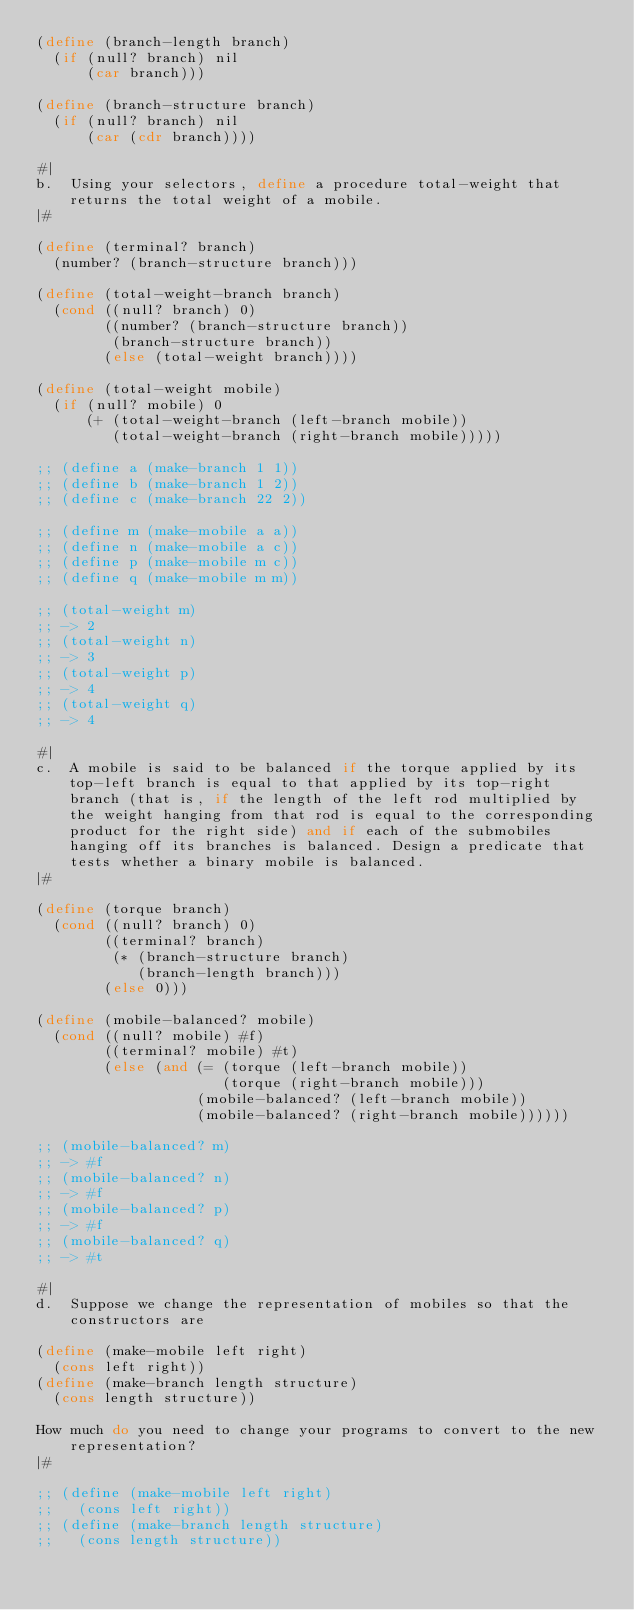Convert code to text. <code><loc_0><loc_0><loc_500><loc_500><_Scheme_>(define (branch-length branch)
  (if (null? branch) nil
      (car branch)))

(define (branch-structure branch)
  (if (null? branch) nil
      (car (cdr branch))))

#|
b.  Using your selectors, define a procedure total-weight that returns the total weight of a mobile.
|#

(define (terminal? branch)
  (number? (branch-structure branch)))

(define (total-weight-branch branch)
  (cond ((null? branch) 0)
        ((number? (branch-structure branch))
         (branch-structure branch))
        (else (total-weight branch))))

(define (total-weight mobile)
  (if (null? mobile) 0
      (+ (total-weight-branch (left-branch mobile))
         (total-weight-branch (right-branch mobile)))))

;; (define a (make-branch 1 1))
;; (define b (make-branch 1 2))
;; (define c (make-branch 22 2))

;; (define m (make-mobile a a))
;; (define n (make-mobile a c))
;; (define p (make-mobile m c))
;; (define q (make-mobile m m))

;; (total-weight m)
;; -> 2
;; (total-weight n)
;; -> 3
;; (total-weight p)
;; -> 4
;; (total-weight q)
;; -> 4

#|
c.  A mobile is said to be balanced if the torque applied by its top-left branch is equal to that applied by its top-right branch (that is, if the length of the left rod multiplied by the weight hanging from that rod is equal to the corresponding product for the right side) and if each of the submobiles hanging off its branches is balanced. Design a predicate that tests whether a binary mobile is balanced.
|#

(define (torque branch)
  (cond ((null? branch) 0)
        ((terminal? branch)
         (* (branch-structure branch)
            (branch-length branch)))
        (else 0)))

(define (mobile-balanced? mobile)
  (cond ((null? mobile) #f)
        ((terminal? mobile) #t)
        (else (and (= (torque (left-branch mobile))
                      (torque (right-branch mobile)))
                   (mobile-balanced? (left-branch mobile))
                   (mobile-balanced? (right-branch mobile))))))

;; (mobile-balanced? m)
;; -> #f
;; (mobile-balanced? n)
;; -> #f
;; (mobile-balanced? p)
;; -> #f
;; (mobile-balanced? q)
;; -> #t

#|
d.  Suppose we change the representation of mobiles so that the constructors are

(define (make-mobile left right)
  (cons left right))
(define (make-branch length structure)
  (cons length structure))

How much do you need to change your programs to convert to the new representation?
|#

;; (define (make-mobile left right)
;;   (cons left right))
;; (define (make-branch length structure)
;;   (cons length structure))
</code> 